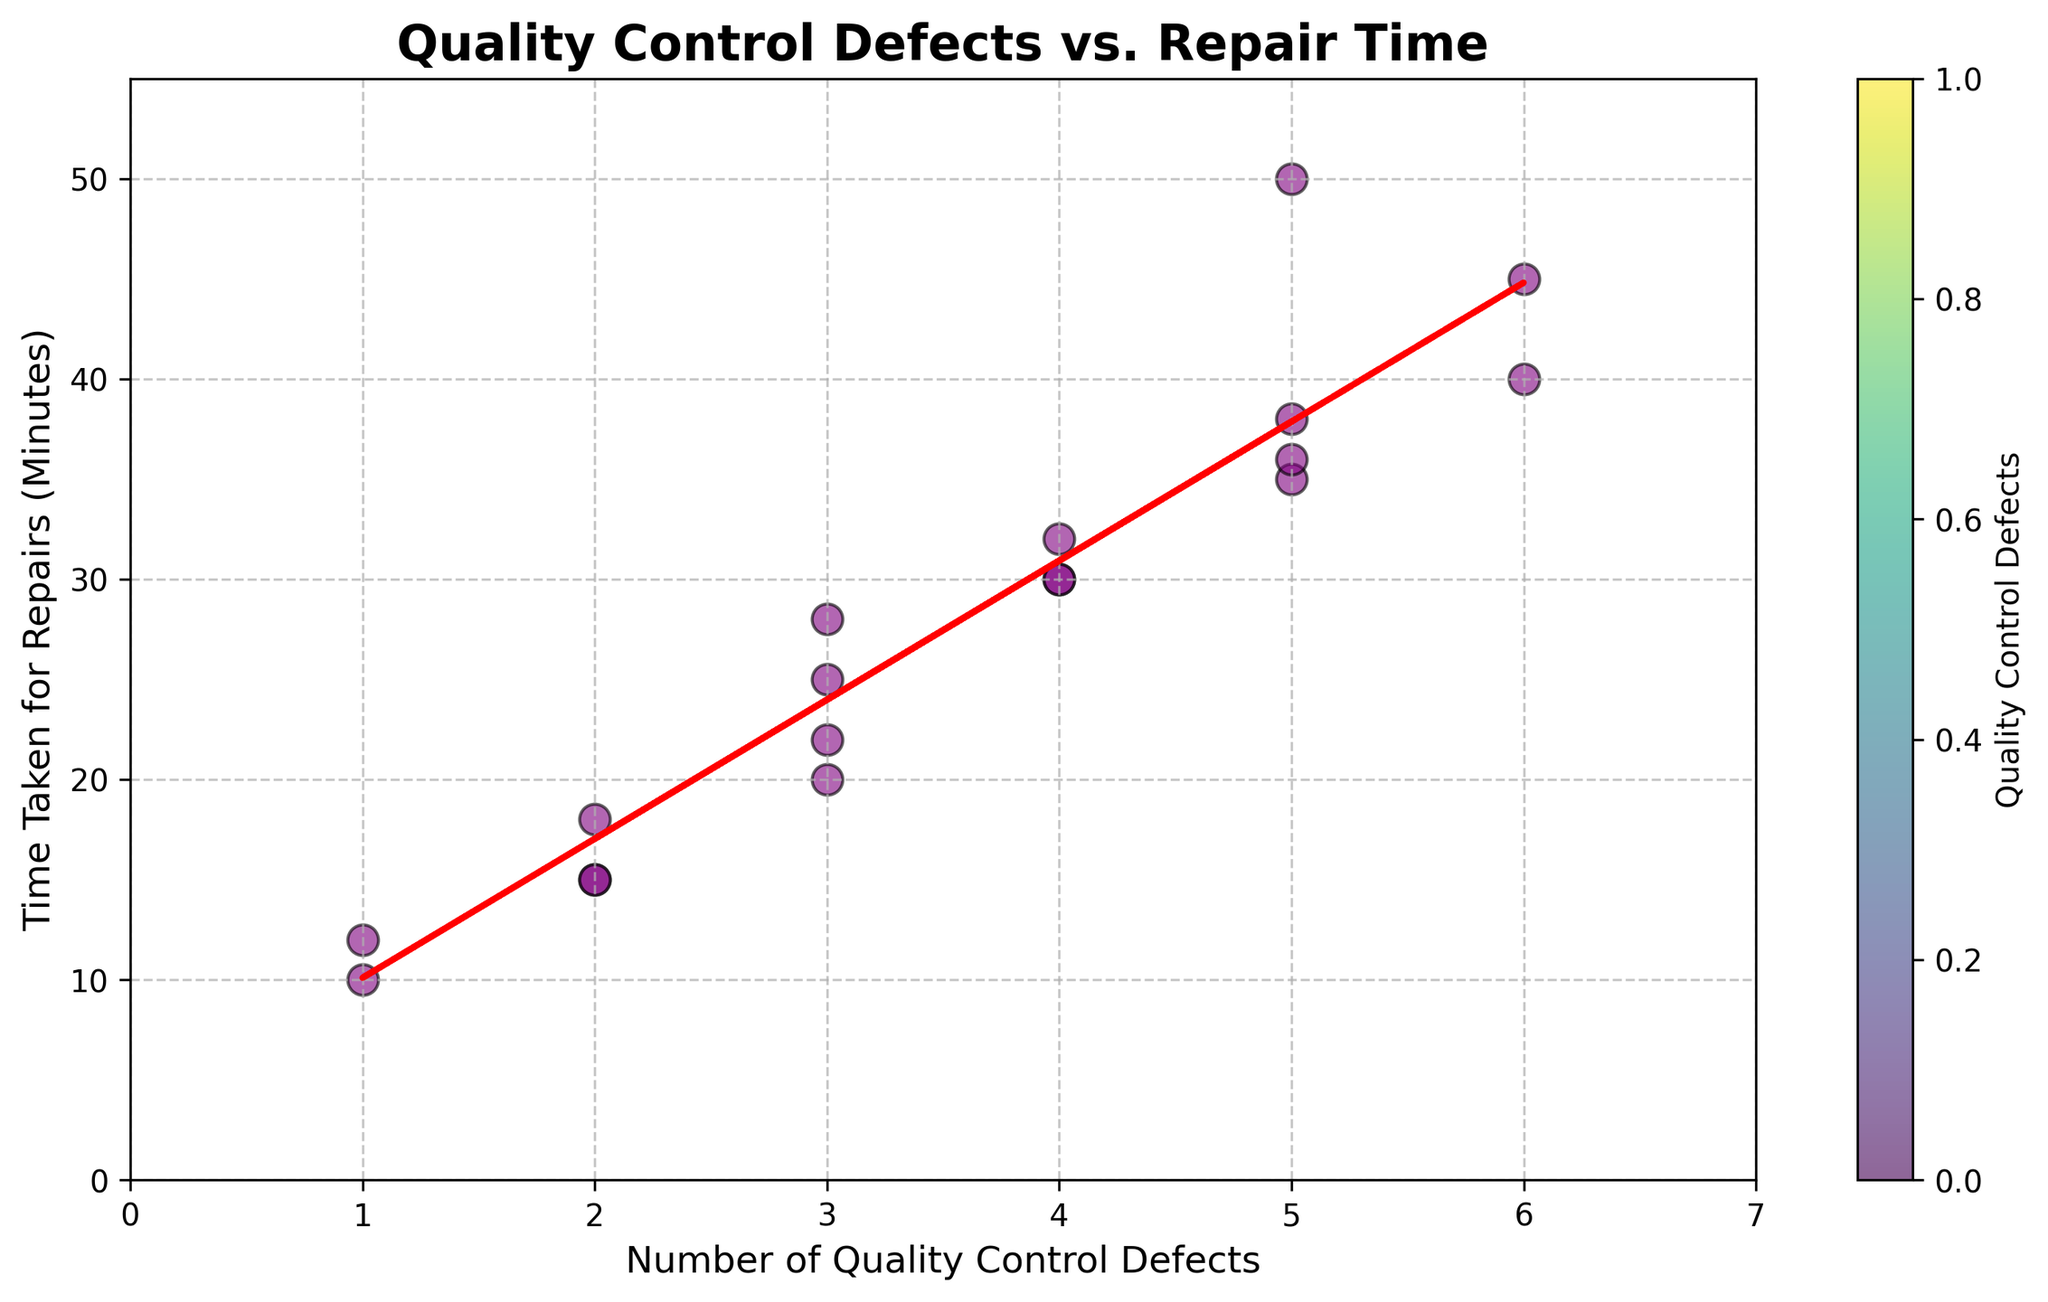How many data points are plotted in the scatter plot? Count the number of data points (dots) visible in the scatter plot. There are 18 dots in the scatter plot.
Answer: 18 What is the title of the scatter plot? The title is displayed at the top of the plot and reads "Quality Control Defects vs. Repair Time".
Answer: Quality Control Defects vs. Repair Time What are the labels for the x-axis and y-axis? The x-axis is labeled "Number of Quality Control Defects," and the y-axis is labeled "Time Taken for Repairs (Minutes)".
Answer: Number of Quality Control Defects; Time Taken for Repairs (Minutes) Does the scatter plot show a positive or negative correlation between the number of defects and repair time? Observe the direction of the trend line. It slopes upward from left to right, indicating a positive correlation.
Answer: Positive What is the approximate slope of the trend line? The trend line can be described by the equation of the line fit `y = mx + c` where `m` is the slope. From the plot, this slope appears to be positive and can be roughly estimated based on the data points fitting around the trend line.
Answer: Approximately 5 (interpretation based on data points) Which data point has the highest repair time and how many defects does it correspond to? Identify the highest point on the y-axis (Time Taken for Repairs) and the corresponding x-axis value (Number of Quality Control Defects). The highest point has a repair time of 50 minutes, corresponding to 5 defects.
Answer: 50 minutes, 5 defects What is the average time taken for repairs across all the data points? To find the average, sum all the repair times and divide by the number of data points: (30 + 15 + 20 + 35 + 10 + 40 + 25 + 15 + 30 + 50 + 12 + 45 + 28 + 32 + 38 + 18 + 36 + 22) / 18 = 461 / 18 ≈ 25.6 minutes
Answer: 25.6 minutes Are there any data points where the number of defects is the same but the repair times are different? If so, how many? Look for distinct repair times with the same number of defects. There are multiple instances, such as when defects = 3, repair times are 20, 25, 28, and 22. Similarly, defects = 4 have repair times 30, 30, and 32.
Answer: Yes, multiple instances Which data point lies closest to the trend line, and how can you identify it? Visually identify which data point lies closest to the dashed red trend line by its distance from the line. The data point at (5, 36) appears very close to the trend line.
Answer: (5, 36) Between two data points with defect counts of 2, how much variance is there in their repair times? Identify the repair times of both data points with 2 defects (15, 15, and 18) and calculate the range: max(18) - min(15) = 3.
Answer: 3 minutes 